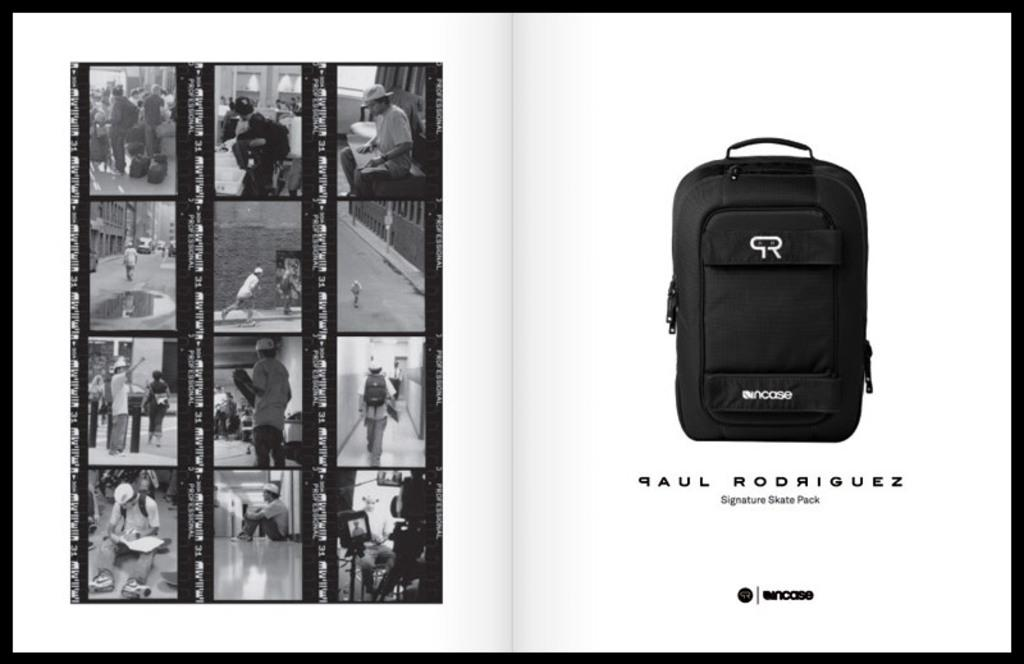What is located on the left side of the image? There is a photo collage on the left side of the image. What can be seen in the photo collage? There are persons in the photos of the collage. What object is on the right side of the image? There is a black color bag on the right side on the right side of the image. What position does the order take in the image? There is no reference to an order or any position in the image, as it features a photo collage and a black color bag. How many times does the person in the photo collage shake hands with the person in the black color bag? There is no interaction between the photo collage and the black color bag in the image, so it is not possible to determine if any shaking of hands occurs. 